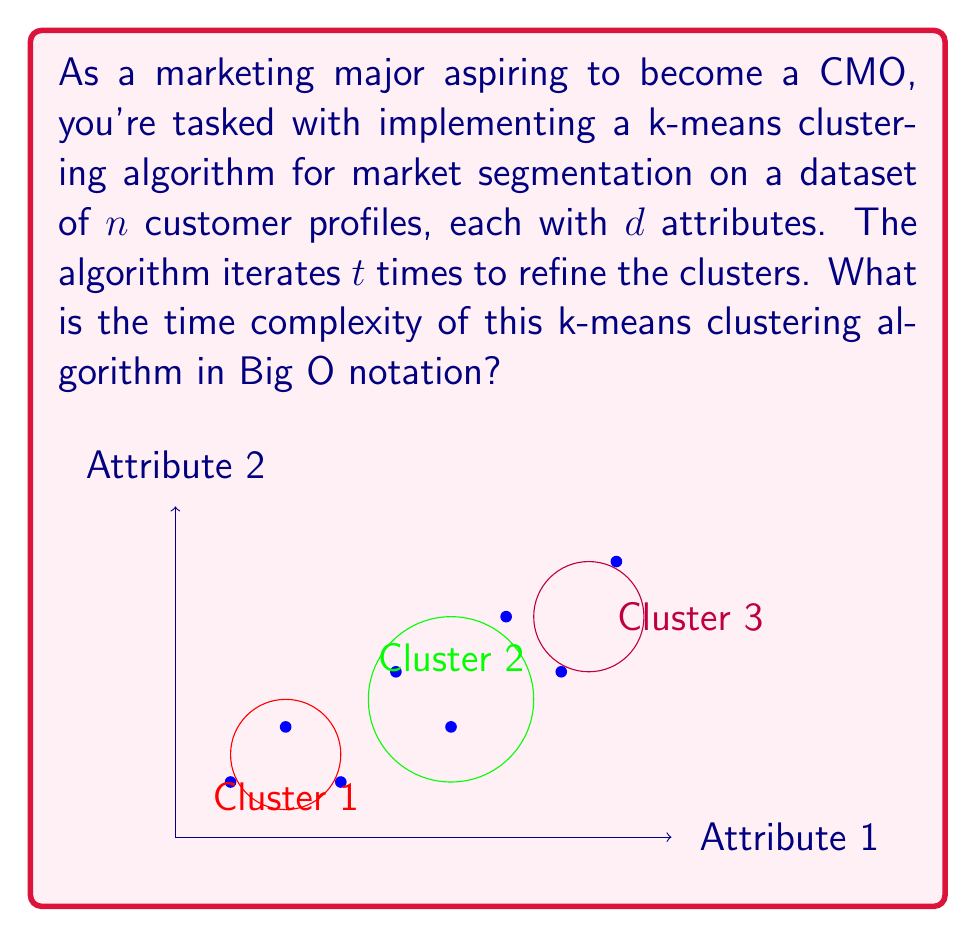Teach me how to tackle this problem. To determine the time complexity of the k-means clustering algorithm for market segmentation, let's break down the process step-by-step:

1. Initialization:
   - Randomly select $k$ initial centroids from the dataset.
   - Time complexity: $O(k)$

2. Main loop (repeated $t$ times):
   a. Assign each point to the nearest centroid:
      - For each of the $n$ points, calculate the distance to all $k$ centroids.
      - Each distance calculation involves $d$ dimensions.
      - Time complexity for this step: $O(nkd)$

   b. Recalculate centroids:
      - For each of the $k$ clusters, calculate the mean of all points in the cluster.
      - This involves summing up to $n$ points (in the worst case) across $d$ dimensions.
      - Time complexity for this step: $O(nkd)$

3. The main loop is repeated $t$ times.

Therefore, the total time complexity is:

$$O(k + t(nkd + nkd)) = O(k + 2tnkd) = O(tnkd)$$

We can simplify this further by noting that $k$ and $d$ are typically much smaller than $n$, and $t$ is often a fixed number of iterations. In practice, we're usually most concerned with how the algorithm scales with the number of data points $n$.
Answer: $O(nkd)$ 